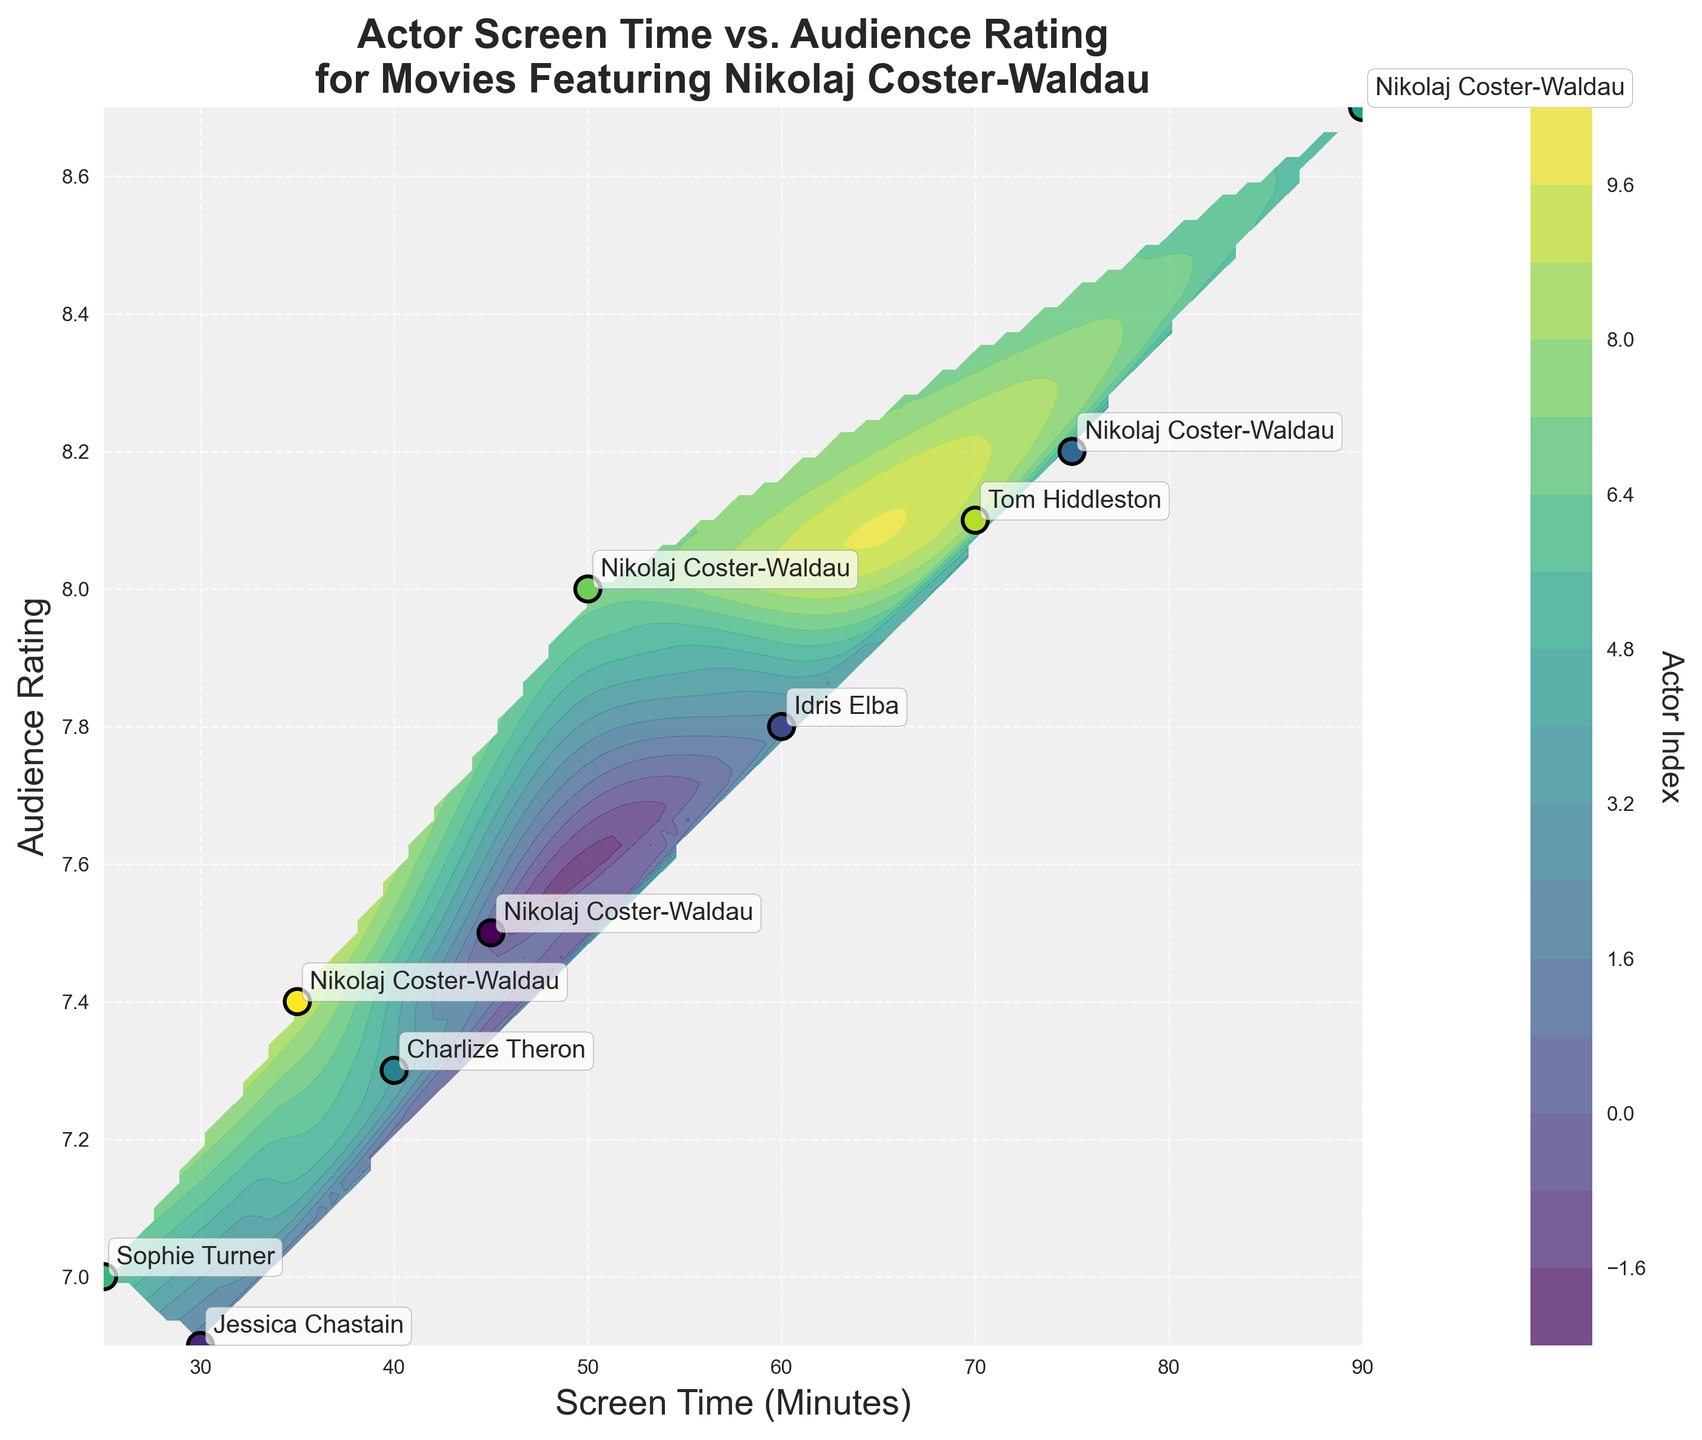Which actor has the highest audience rating in the plot? Locate the dots and labels on the plot to identify the actor with the highest y-value. The actor with the highest audience rating is Nikolaj Coster-Waldau, with a rating of 8.7.
Answer: Nikolaj Coster-Waldau What's the title of the plot? The title of the plot is typically positioned at the top center of the plot. The title reads, "Actor Screen Time vs. Audience Rating for Movies Featuring Nikolaj Coster-Waldau".
Answer: Actor Screen Time vs. Audience Rating for Movies Featuring Nikolaj Coster-Waldau How many data points represent Nikolaj Coster-Waldau? Count the number of labels for Nikolaj Coster-Waldau on the plot. He appears five times on the plot.
Answer: 5 What is the color used for the contour plot background, and how is it typically created? The color of the contour plot is visible in the background shades. The contour plot uses shades of colors, typically ranging from light to dark to represent different levels, created using a colormap like 'viridis'.
Answer: Shades ranging from light to dark How are the other actors labeled in relation to Nikolaj Coster-Waldau in terms of screen time and audience rating? Compare the screen times and audience ratings of other actors by looking at their respective positions on the x and y axes relative to those of Nikolaj.
Answer: Other actors generally have lower screen times and audience ratings Which actor has the lowest screen time? Identify the actor with the smallest x-value (Screen Time). Sophie Turner has the lowest screen time of 25 minutes.
Answer: Sophie Turner Which actor has the closest screen time compared to Nikolaj Coster-Waldau's lowest screen time in the plot? Find Nikolaj's lowest screen time at 35 minutes and compare it with others to see which actor's screen time is closest to that value. Jessica Chastain, with a screen time of 30 minutes, is closest.
Answer: Jessica Chastain Are there any actors with an audience rating between 8.0 and 8.5? If so, who are they? Check the y-axis and find dots within the 8.0 to 8.5 range. Identify the labels corresponding to these points. Nikolaj Coster-Waldau with an 8.2 rating and Idris Elba with an 8.1 rating are within this range.
Answer: Nikolaj Coster-Waldau, Idris Elba What is the actor index used for in the colorbar, and what does it represent in context to the plot? The colorbar explains the mapping of colors to actor indices, which helps to differentiate between the actors' data points. The index order generally corresponds to the order in the dataset.
Answer: It differentiates actors visually 